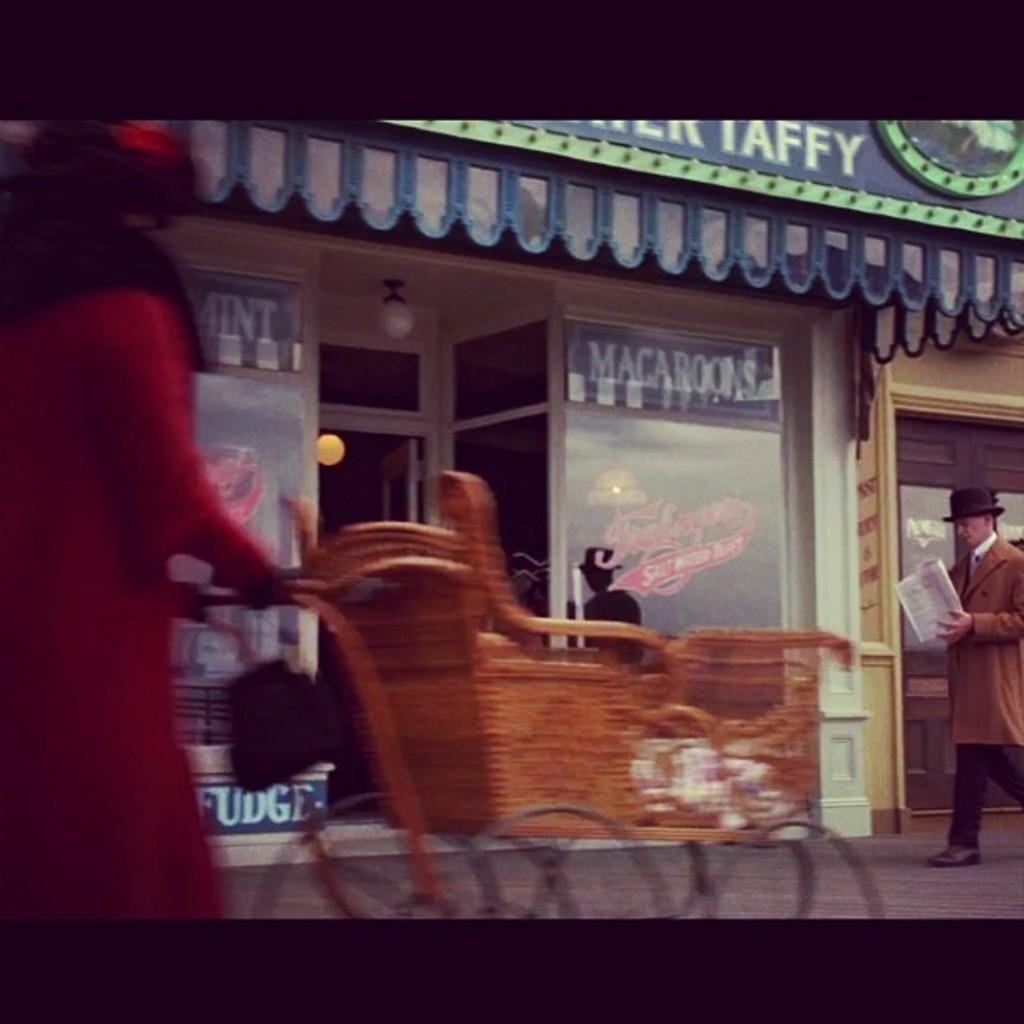What is the person holding in the image? The person is holding a brown color vehicle in the image. What can be seen in the background of the image? There are stores, lights, glass windows, and a door visible in the background of the image. What else is the person holding in the image? There is a person holding a paper in the image. What type of cheese is being used to clean the glass windows in the image? There is no cheese present in the image, and the glass windows are not being cleaned. 